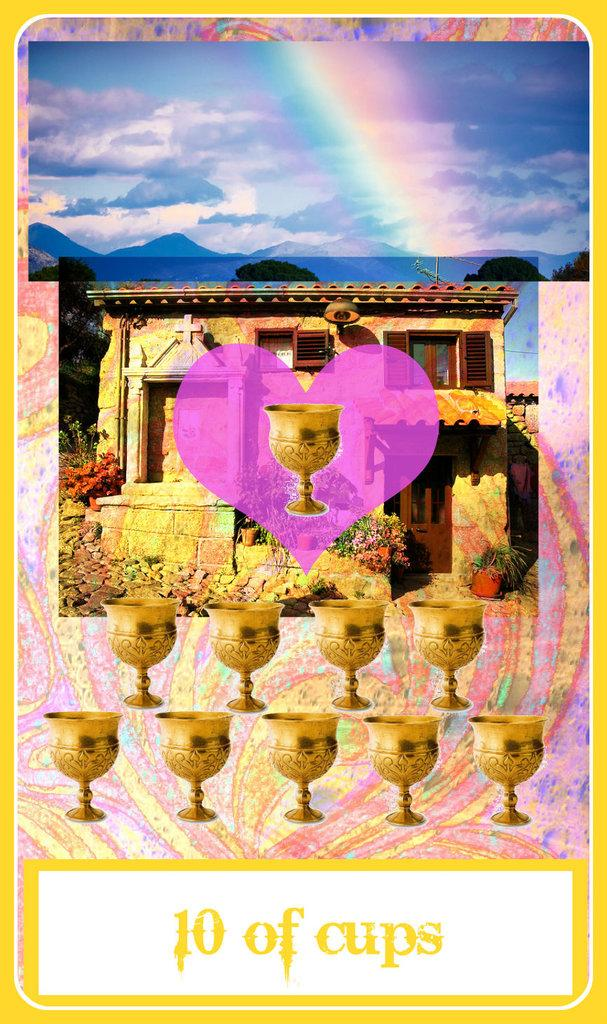<image>
Relay a brief, clear account of the picture shown. A card for the 10 of cups has a pink hart in the middle of it. 